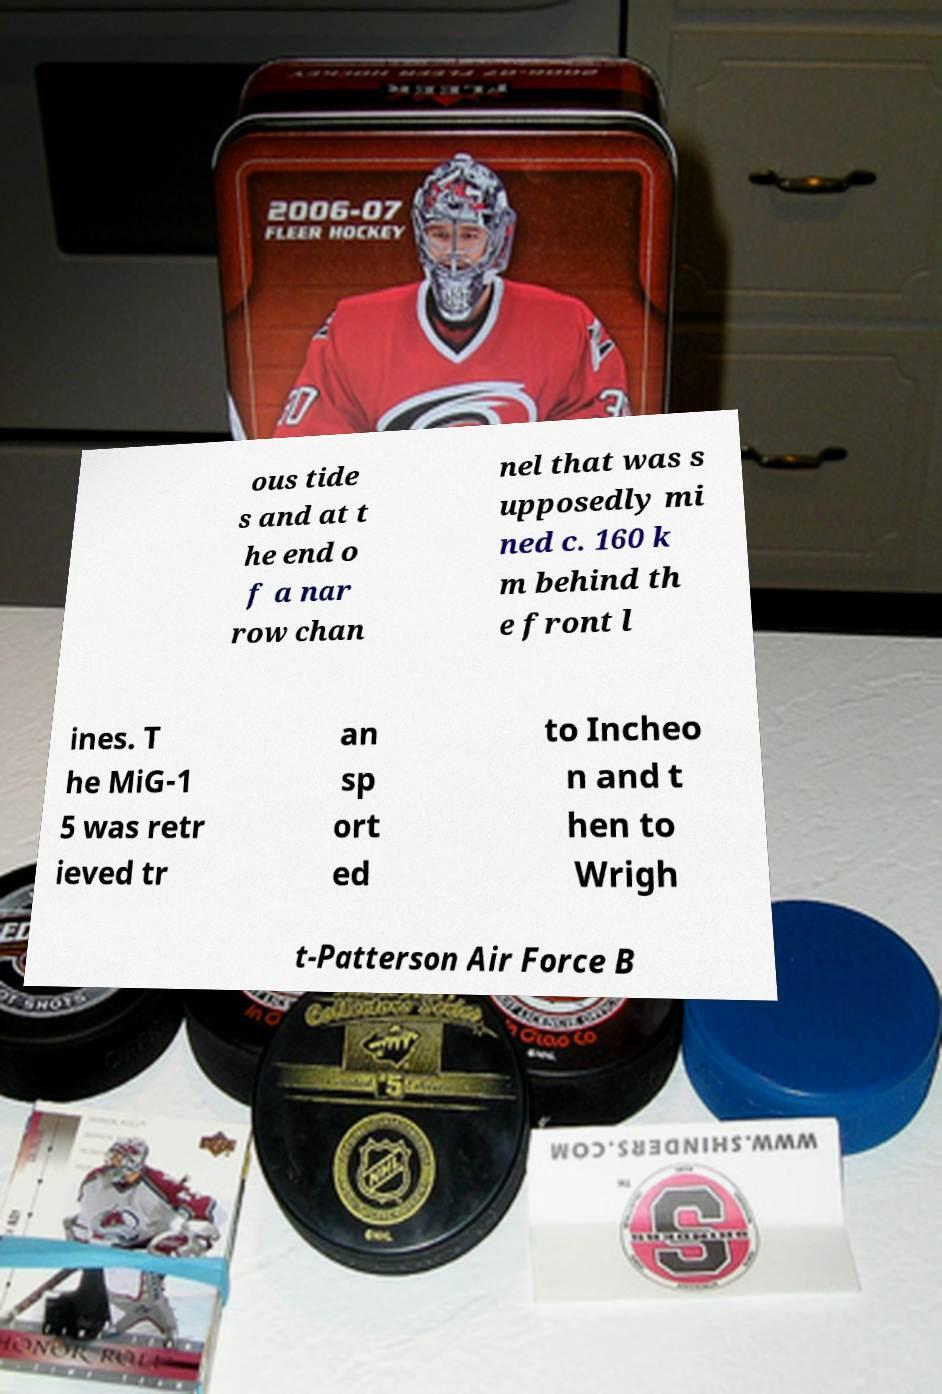I need the written content from this picture converted into text. Can you do that? ous tide s and at t he end o f a nar row chan nel that was s upposedly mi ned c. 160 k m behind th e front l ines. T he MiG-1 5 was retr ieved tr an sp ort ed to Incheo n and t hen to Wrigh t-Patterson Air Force B 